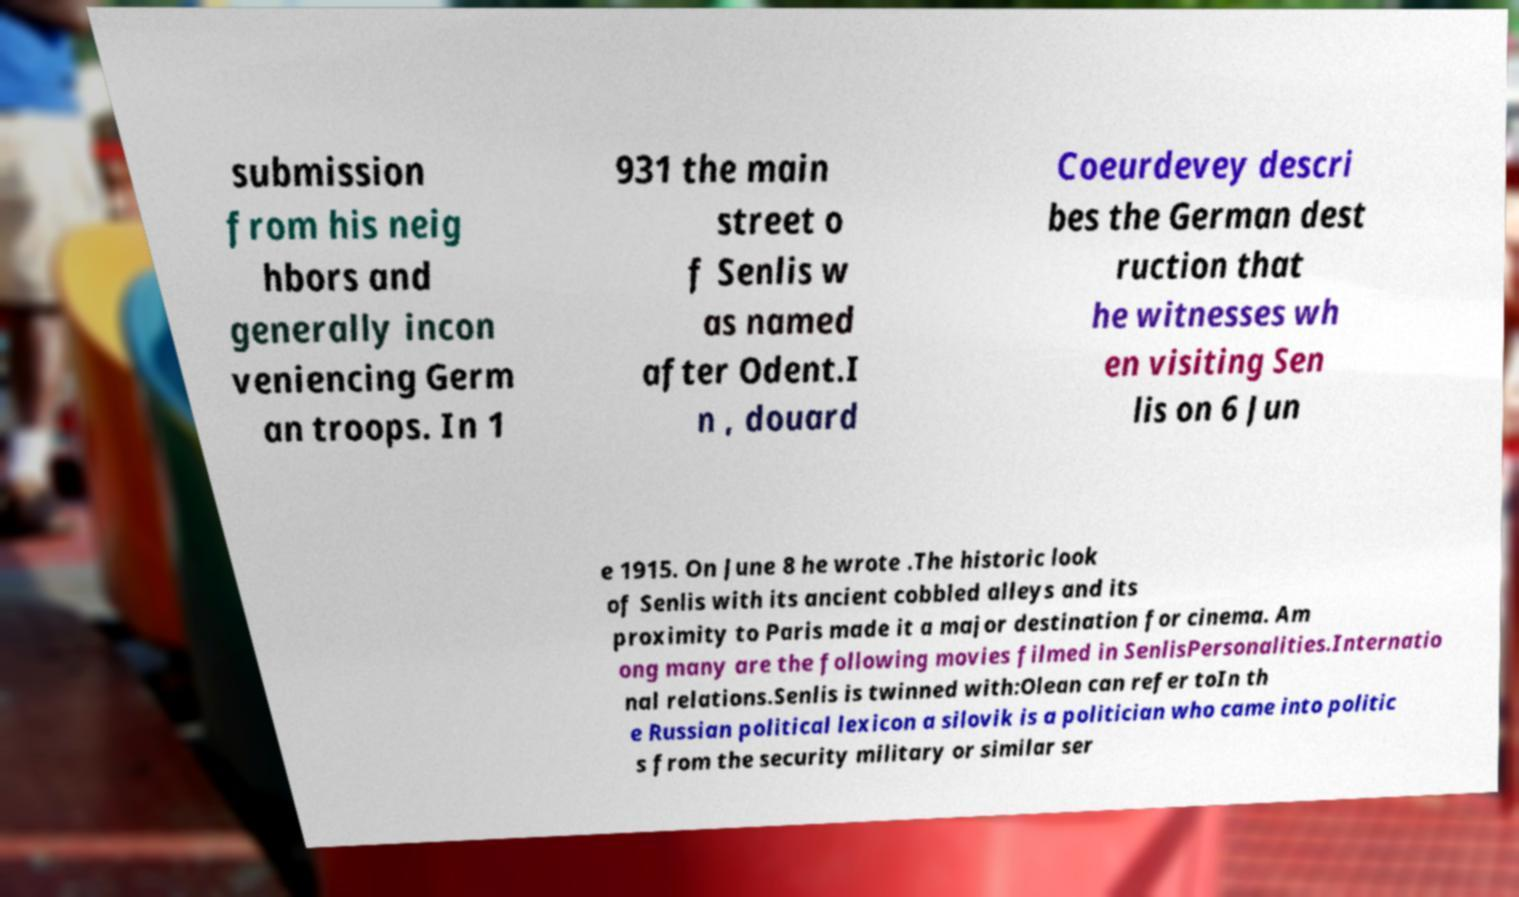Can you read and provide the text displayed in the image?This photo seems to have some interesting text. Can you extract and type it out for me? submission from his neig hbors and generally incon veniencing Germ an troops. In 1 931 the main street o f Senlis w as named after Odent.I n , douard Coeurdevey descri bes the German dest ruction that he witnesses wh en visiting Sen lis on 6 Jun e 1915. On June 8 he wrote .The historic look of Senlis with its ancient cobbled alleys and its proximity to Paris made it a major destination for cinema. Am ong many are the following movies filmed in SenlisPersonalities.Internatio nal relations.Senlis is twinned with:Olean can refer toIn th e Russian political lexicon a silovik is a politician who came into politic s from the security military or similar ser 